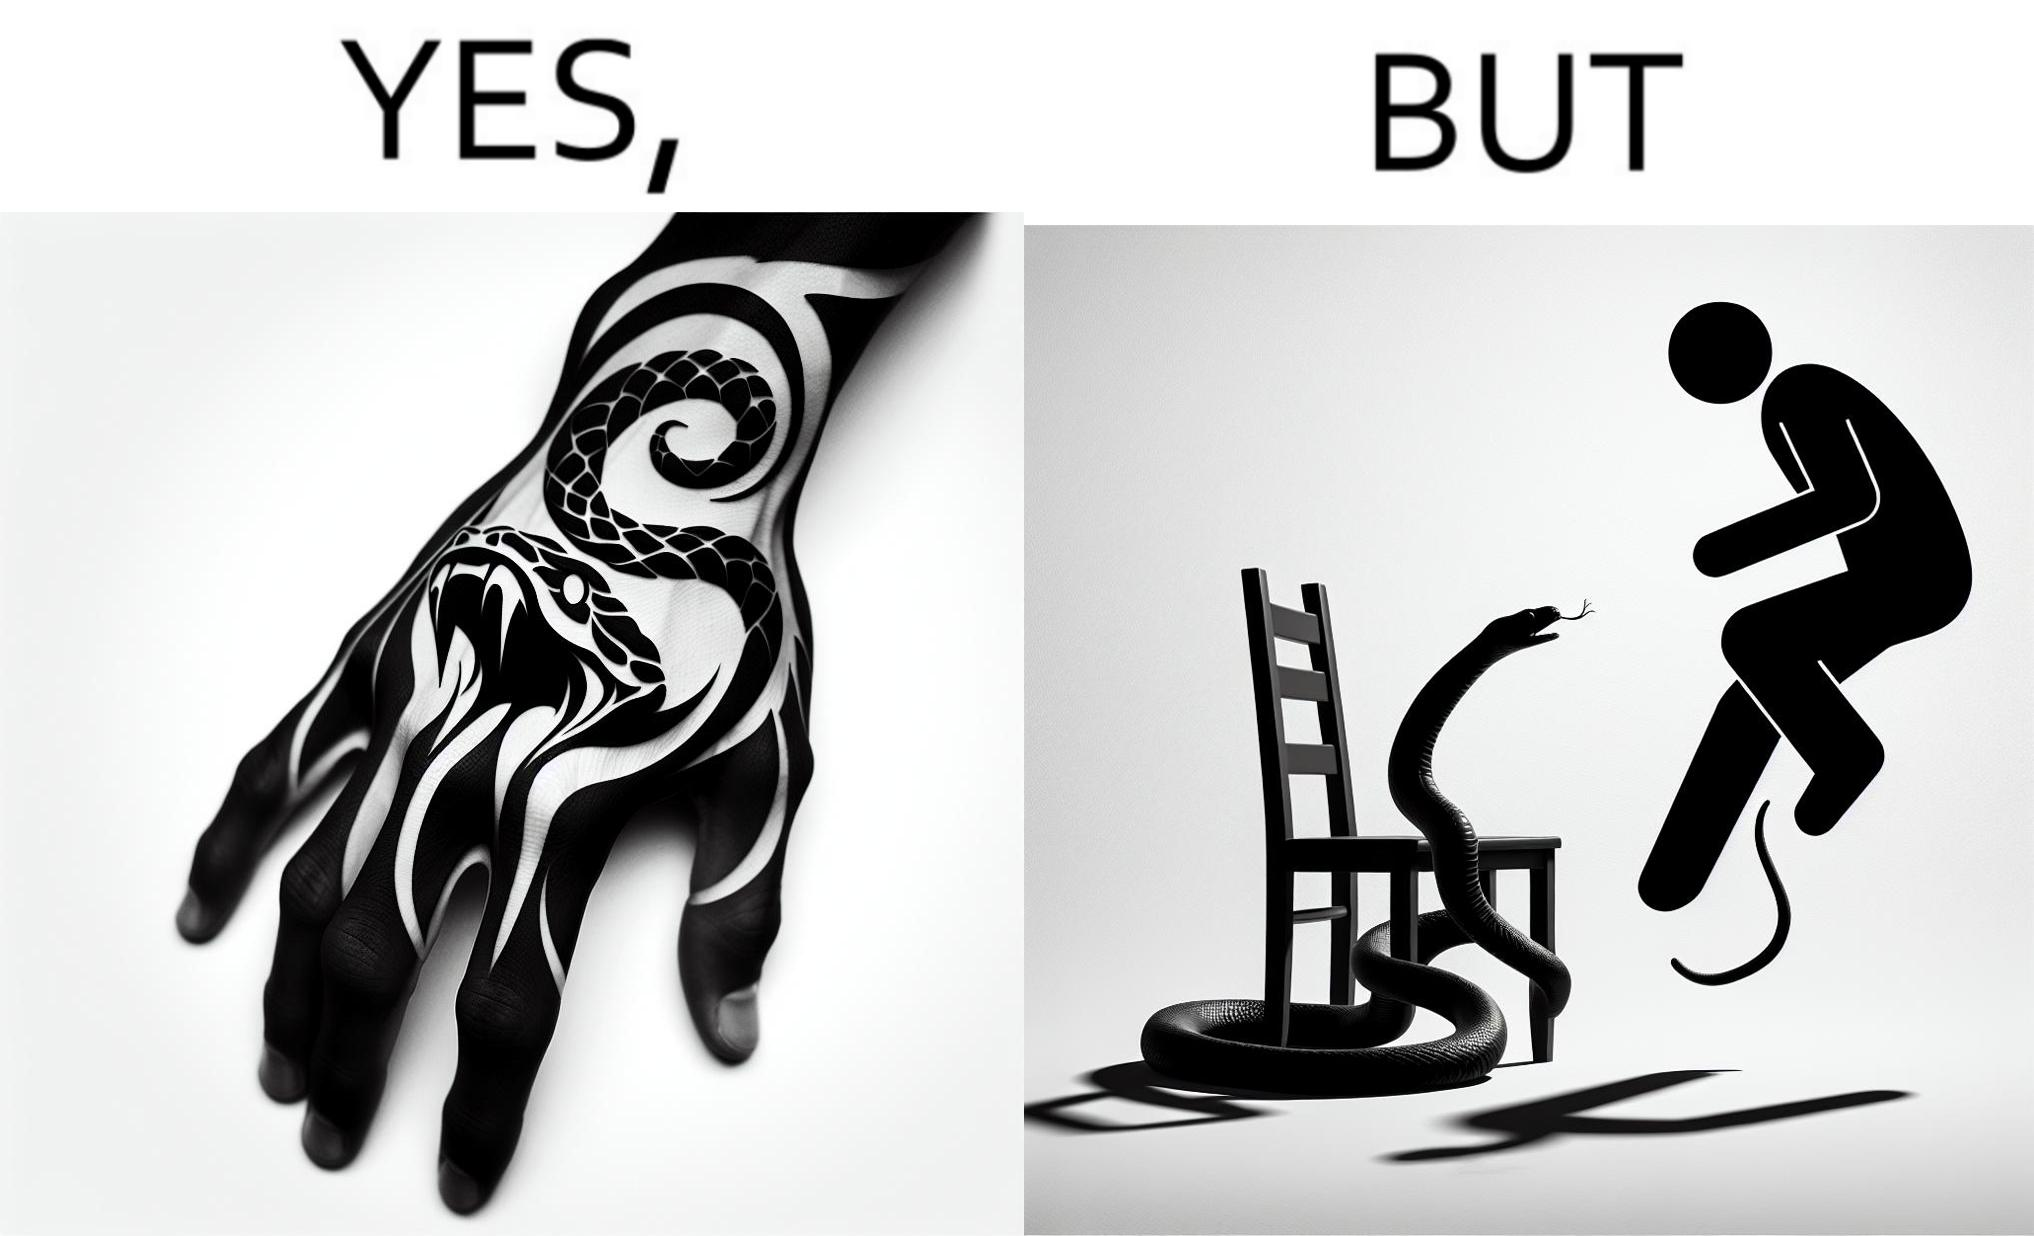What is shown in the left half versus the right half of this image? In the left part of the image: a tattoo of a snake with its mouth wide open on someone's hand In the right part of the image: a person standing on a chair trying save himself from the attack of snake and the snake is probably trying to climb up the chair 